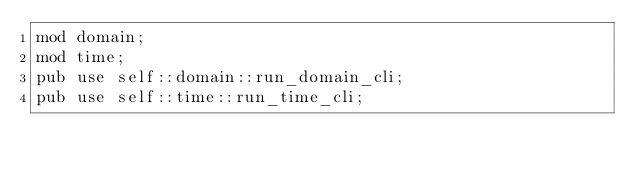<code> <loc_0><loc_0><loc_500><loc_500><_Rust_>mod domain;
mod time;
pub use self::domain::run_domain_cli;
pub use self::time::run_time_cli;
</code> 